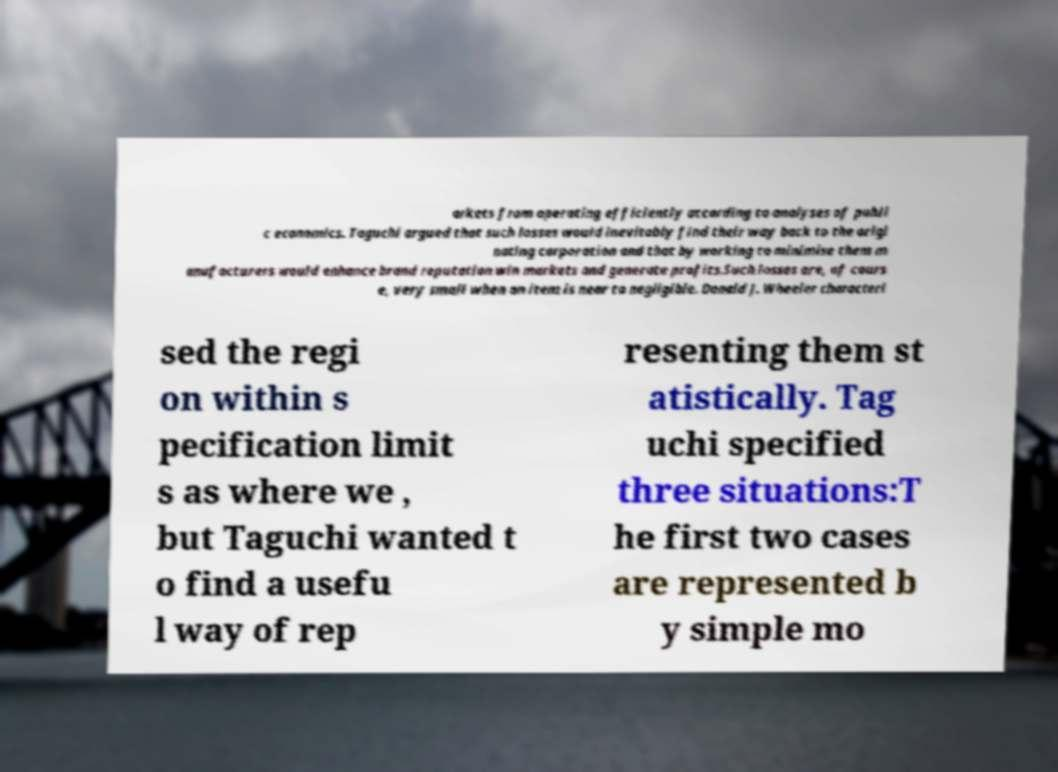Please read and relay the text visible in this image. What does it say? arkets from operating efficiently according to analyses of publi c economics. Taguchi argued that such losses would inevitably find their way back to the origi nating corporation and that by working to minimise them m anufacturers would enhance brand reputation win markets and generate profits.Such losses are, of cours e, very small when an item is near to negligible. Donald J. Wheeler characteri sed the regi on within s pecification limit s as where we , but Taguchi wanted t o find a usefu l way of rep resenting them st atistically. Tag uchi specified three situations:T he first two cases are represented b y simple mo 